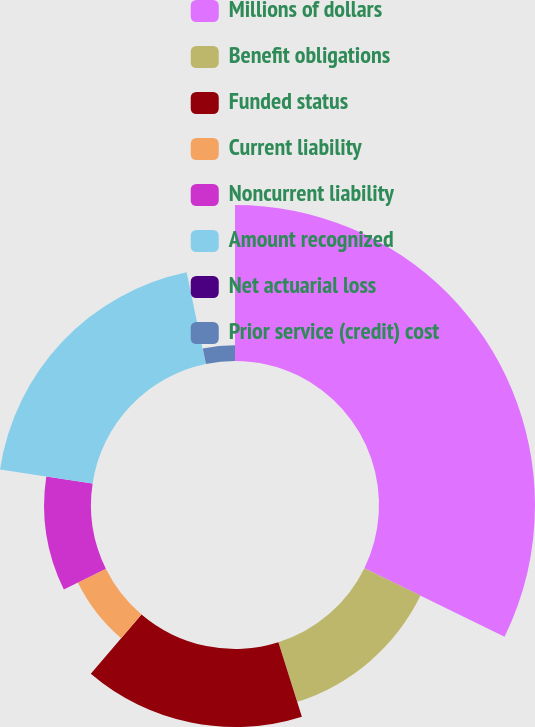Convert chart. <chart><loc_0><loc_0><loc_500><loc_500><pie_chart><fcel>Millions of dollars<fcel>Benefit obligations<fcel>Funded status<fcel>Current liability<fcel>Noncurrent liability<fcel>Amount recognized<fcel>Net actuarial loss<fcel>Prior service (credit) cost<nl><fcel>32.23%<fcel>12.9%<fcel>16.12%<fcel>6.46%<fcel>9.68%<fcel>19.35%<fcel>0.02%<fcel>3.24%<nl></chart> 